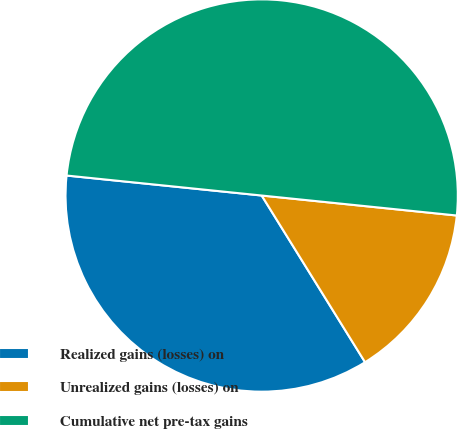Convert chart to OTSL. <chart><loc_0><loc_0><loc_500><loc_500><pie_chart><fcel>Realized gains (losses) on<fcel>Unrealized gains (losses) on<fcel>Cumulative net pre-tax gains<nl><fcel>35.46%<fcel>14.54%<fcel>50.0%<nl></chart> 